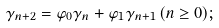Convert formula to latex. <formula><loc_0><loc_0><loc_500><loc_500>\gamma _ { n + 2 } = \varphi _ { 0 } \gamma _ { n } + \varphi _ { 1 } \gamma _ { n + 1 } \, ( n \geq 0 ) ;</formula> 